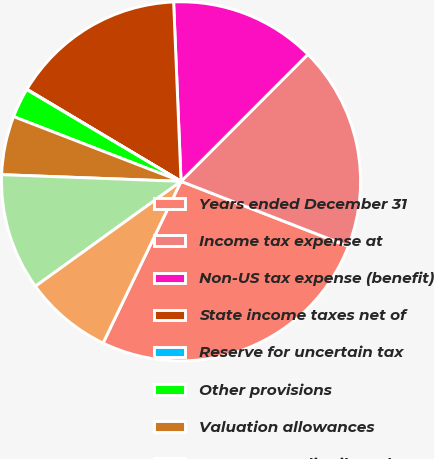Convert chart. <chart><loc_0><loc_0><loc_500><loc_500><pie_chart><fcel>Years ended December 31<fcel>Income tax expense at<fcel>Non-US tax expense (benefit)<fcel>State income taxes net of<fcel>Reserve for uncertain tax<fcel>Other provisions<fcel>Valuation allowances<fcel>US tax on undistributed non-US<fcel>Stock compensation<nl><fcel>26.26%<fcel>18.4%<fcel>13.15%<fcel>15.77%<fcel>0.04%<fcel>2.66%<fcel>5.28%<fcel>10.53%<fcel>7.91%<nl></chart> 